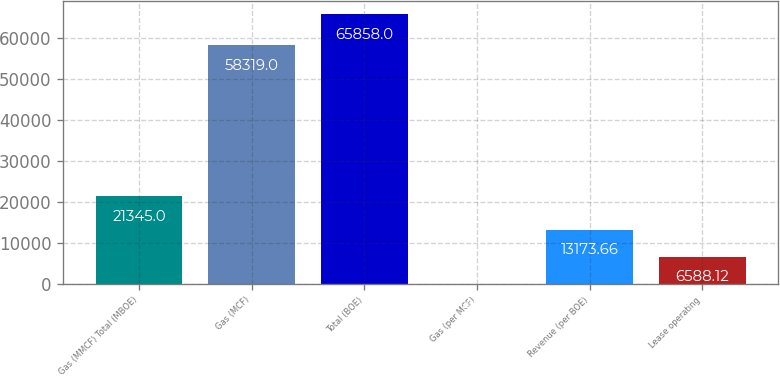<chart> <loc_0><loc_0><loc_500><loc_500><bar_chart><fcel>Gas (MMCF) Total (MBOE)<fcel>Gas (MCF)<fcel>Total (BOE)<fcel>Gas (per MCF)<fcel>Revenue (per BOE)<fcel>Lease operating<nl><fcel>21345<fcel>58319<fcel>65858<fcel>2.58<fcel>13173.7<fcel>6588.12<nl></chart> 